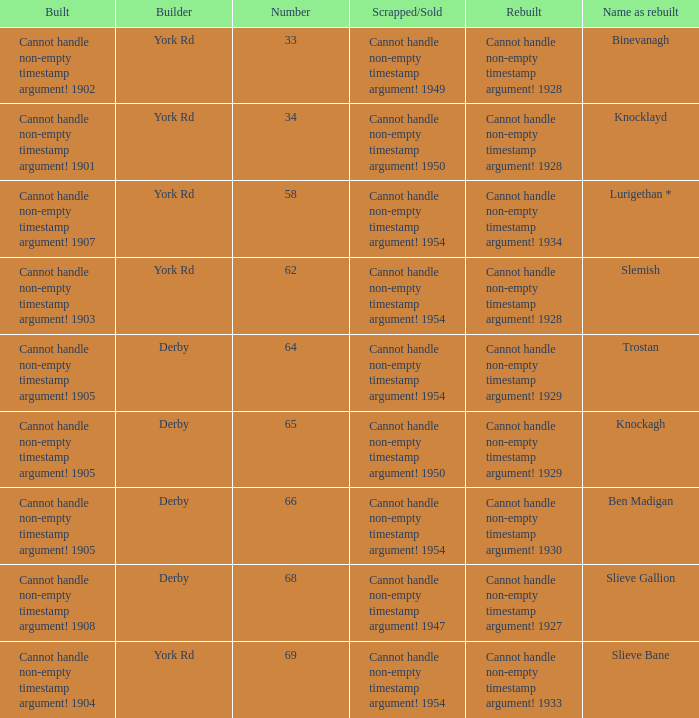Which Rebuilt has a Builder of derby, and a Name as rebuilt of ben madigan? Cannot handle non-empty timestamp argument! 1930. 